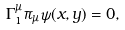<formula> <loc_0><loc_0><loc_500><loc_500>\Gamma _ { 1 } ^ { \mu } \pi _ { \mu } \psi ( x , y ) = 0 ,</formula> 